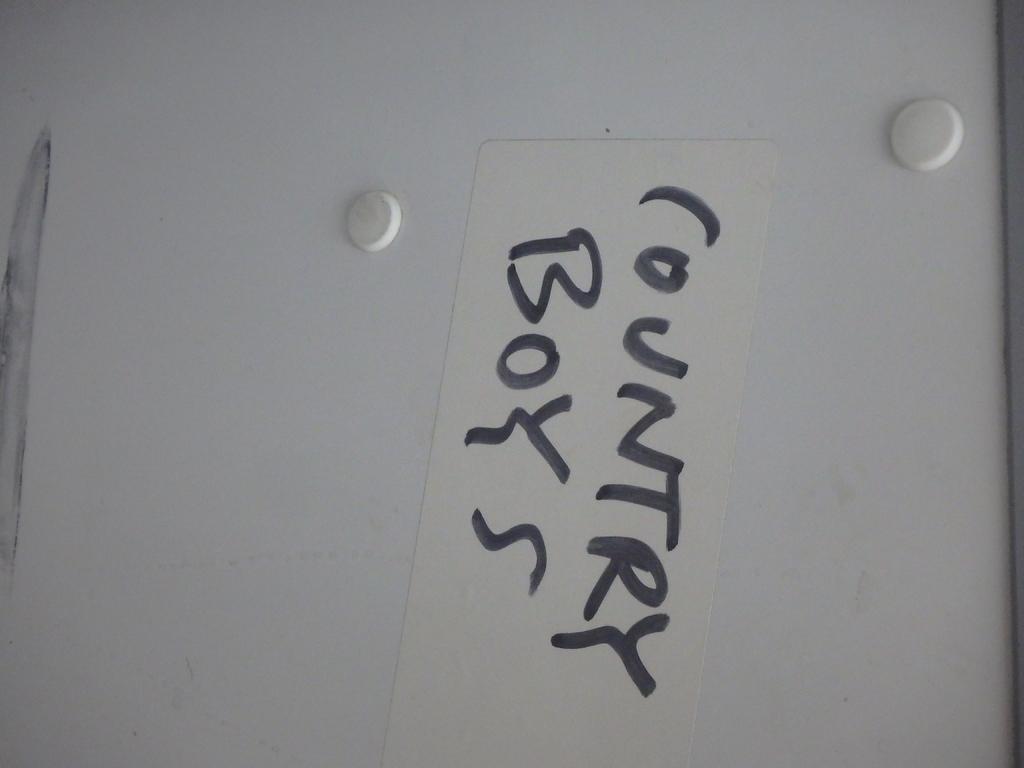Can you describe this image briefly? In this I can see black color text on a white color board. 